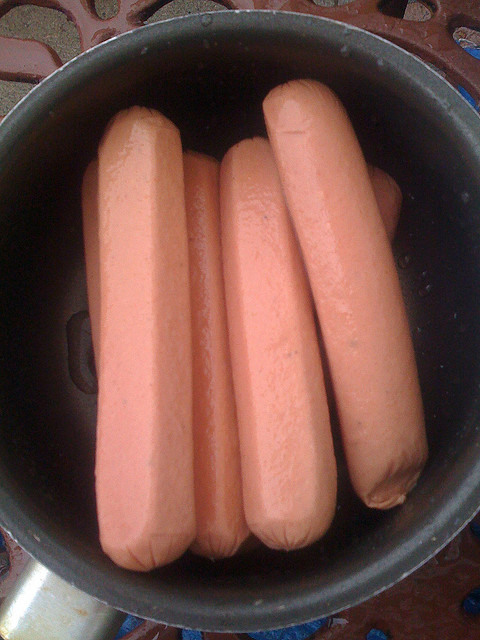What is bad about this food? A. high sugar B. high sodium C. high fat D. high carb While hot dogs can contain various elements that might be considered unhealthy, option B 'high sodium' is often a significant concern. Processed meats like hot dogs tend to contain high amounts of sodium, which can contribute to health issues when consumed in excess, including high blood pressure and heart disease. It's important to consume such food in moderation as part of a balanced diet. 